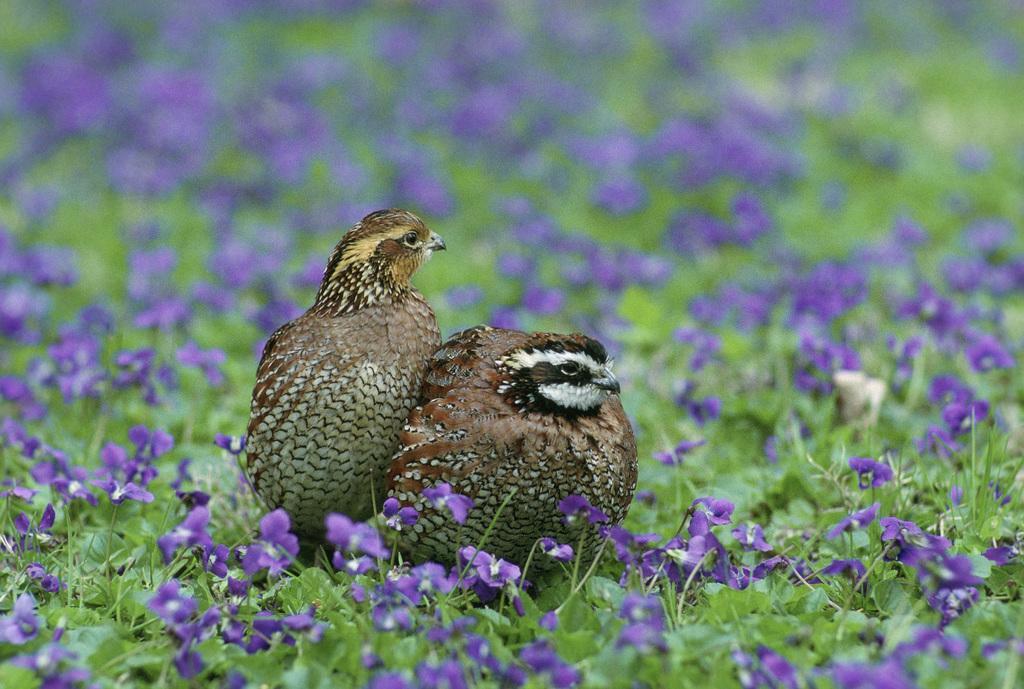How would you summarize this image in a sentence or two? In this image, we can see some plants. There are birds in the middle of the image. In the background, image is blurred. 